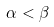<formula> <loc_0><loc_0><loc_500><loc_500>\alpha < \beta</formula> 